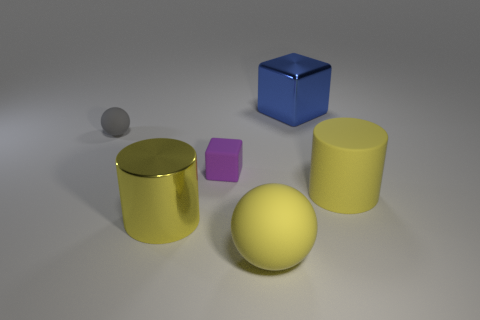Add 3 big yellow rubber spheres. How many objects exist? 9 Subtract all spheres. How many objects are left? 4 Add 6 small rubber things. How many small rubber things are left? 8 Add 5 small purple things. How many small purple things exist? 6 Subtract 0 brown balls. How many objects are left? 6 Subtract all big red matte cubes. Subtract all large blue blocks. How many objects are left? 5 